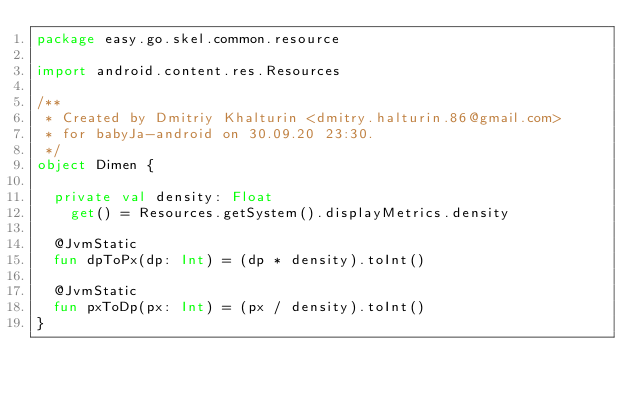Convert code to text. <code><loc_0><loc_0><loc_500><loc_500><_Kotlin_>package easy.go.skel.common.resource

import android.content.res.Resources

/**
 * Created by Dmitriy Khalturin <dmitry.halturin.86@gmail.com>
 * for babyJa-android on 30.09.20 23:30.
 */
object Dimen {

  private val density: Float
    get() = Resources.getSystem().displayMetrics.density

  @JvmStatic
  fun dpToPx(dp: Int) = (dp * density).toInt()

  @JvmStatic
  fun pxToDp(px: Int) = (px / density).toInt()
}
</code> 